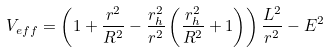<formula> <loc_0><loc_0><loc_500><loc_500>V _ { e f f } = \left ( 1 + \frac { r ^ { 2 } } { R ^ { 2 } } - \frac { r _ { h } ^ { 2 } } { r ^ { 2 } } \left ( \frac { r _ { h } ^ { 2 } } { R ^ { 2 } } + 1 \right ) \right ) \frac { L ^ { 2 } } { r ^ { 2 } } - E ^ { 2 }</formula> 